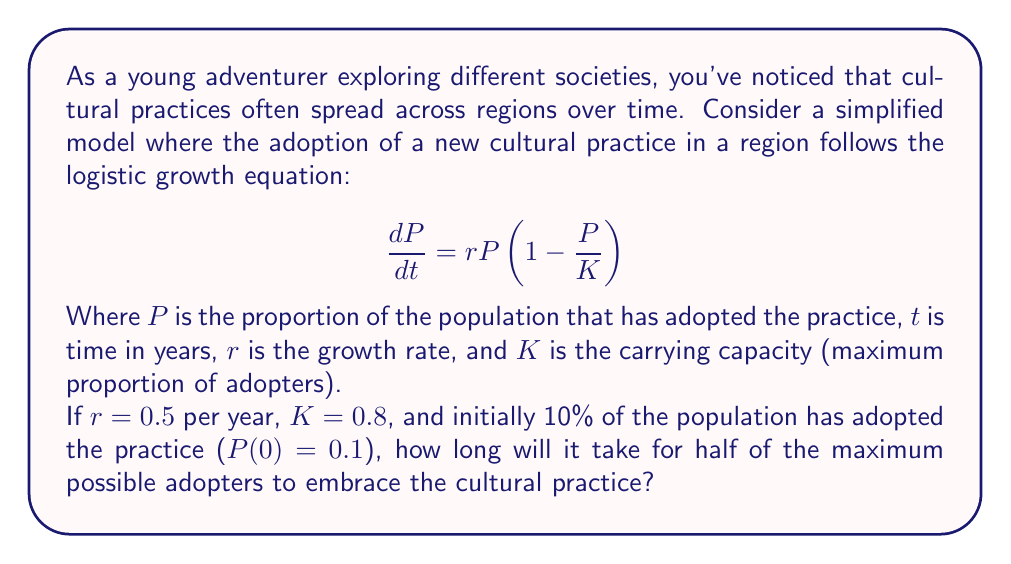What is the answer to this math problem? To solve this problem, we need to follow these steps:

1) The logistic equation solution is given by:

   $$P(t) = \frac{K}{1 + (\frac{K}{P_0} - 1)e^{-rt}}$$

   Where $P_0$ is the initial proportion of adopters.

2) We're asked to find when half of the maximum possible adopters have embraced the practice. This means we're looking for $P(t) = 0.5K = 0.5(0.8) = 0.4$.

3) Let's substitute the known values into the equation:

   $$0.4 = \frac{0.8}{1 + (\frac{0.8}{0.1} - 1)e^{-0.5t}}$$

4) Simplify:

   $$0.4 = \frac{0.8}{1 + 7e^{-0.5t}}$$

5) Multiply both sides by the denominator:

   $$0.4(1 + 7e^{-0.5t}) = 0.8$$

6) Distribute:

   $$0.4 + 2.8e^{-0.5t} = 0.8$$

7) Subtract 0.4 from both sides:

   $$2.8e^{-0.5t} = 0.4$$

8) Divide both sides by 2.8:

   $$e^{-0.5t} = \frac{1}{7}$$

9) Take the natural log of both sides:

   $$-0.5t = \ln(\frac{1}{7})$$

10) Divide both sides by -0.5:

    $$t = -\frac{2}{1}\ln(\frac{1}{7}) = 2\ln(7) \approx 3.89$$

Therefore, it will take approximately 3.89 years for half of the maximum possible adopters to embrace the cultural practice.
Answer: $t = 2\ln(7) \approx 3.89$ years 